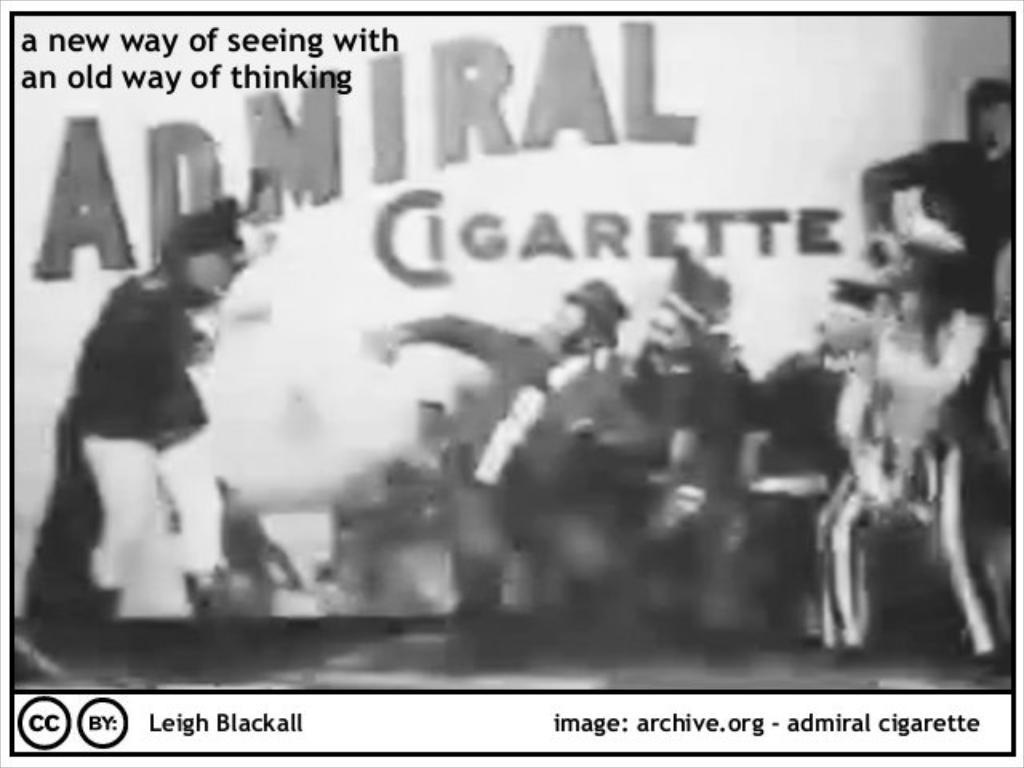What is the color scheme of the image? The image is black and white. What can be seen in the image besides the color scheme? There is a poster and text in the image. Can you describe the poster in the image? Unfortunately, the image is blurry, so it's difficult to provide a detailed description of the poster. What type of quilt is being used for teaching in the image? There is no quilt or teaching activity present in the image. Can you describe the stream that is visible in the image? There is no stream visible in the image; it is a black and white image with a poster and text. 